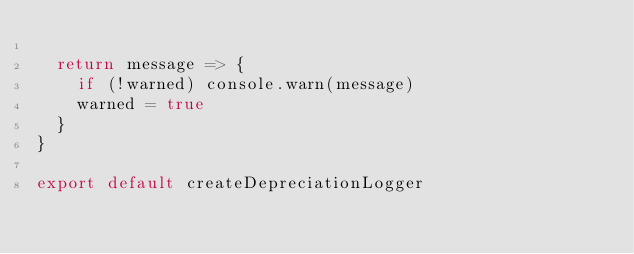Convert code to text. <code><loc_0><loc_0><loc_500><loc_500><_JavaScript_>
  return message => {
    if (!warned) console.warn(message)
    warned = true
  }
}

export default createDepreciationLogger
</code> 